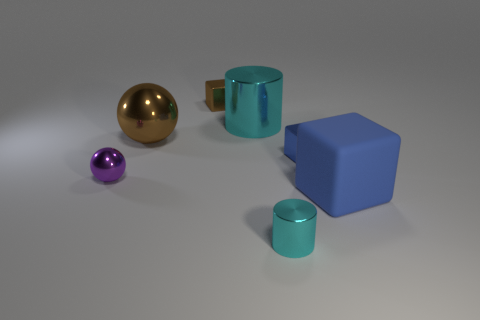Add 2 small cylinders. How many objects exist? 9 Subtract all blocks. How many objects are left? 4 Add 2 purple shiny objects. How many purple shiny objects are left? 3 Add 3 blue things. How many blue things exist? 5 Subtract 0 yellow blocks. How many objects are left? 7 Subtract all yellow metallic cylinders. Subtract all tiny blue objects. How many objects are left? 6 